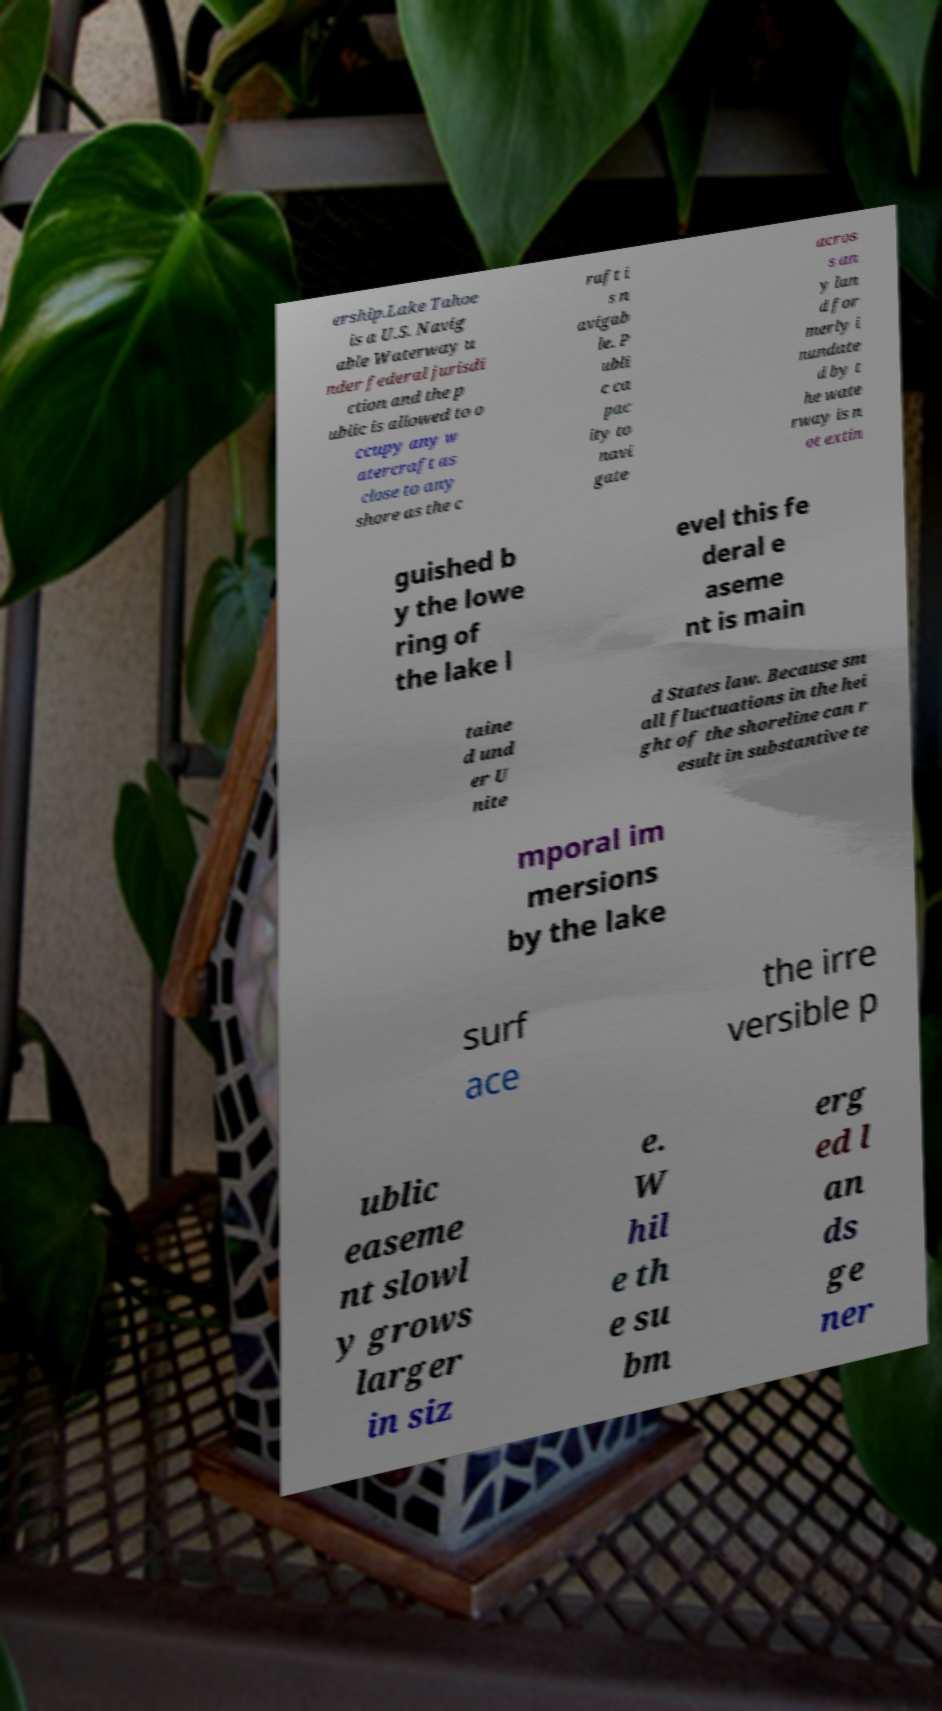What messages or text are displayed in this image? I need them in a readable, typed format. ership.Lake Tahoe is a U.S. Navig able Waterway u nder federal jurisdi ction and the p ublic is allowed to o ccupy any w atercraft as close to any shore as the c raft i s n avigab le. P ubli c ca pac ity to navi gate acros s an y lan d for merly i nundate d by t he wate rway is n ot extin guished b y the lowe ring of the lake l evel this fe deral e aseme nt is main taine d und er U nite d States law. Because sm all fluctuations in the hei ght of the shoreline can r esult in substantive te mporal im mersions by the lake surf ace the irre versible p ublic easeme nt slowl y grows larger in siz e. W hil e th e su bm erg ed l an ds ge ner 